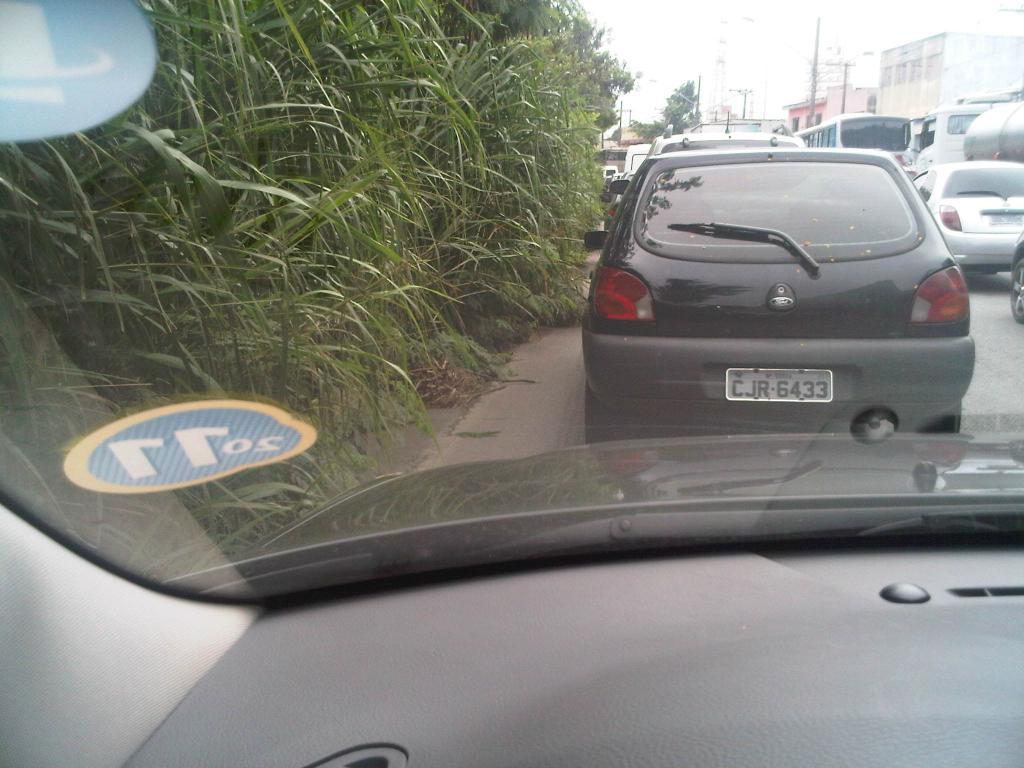What numbers are on the windshield sticker on the car?
Make the answer very short. 2011. 